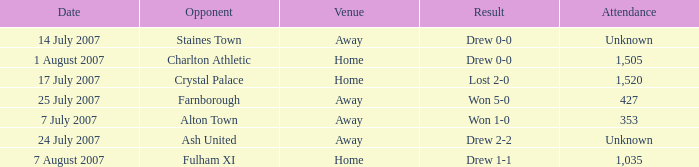Name the venue for staines town Away. 